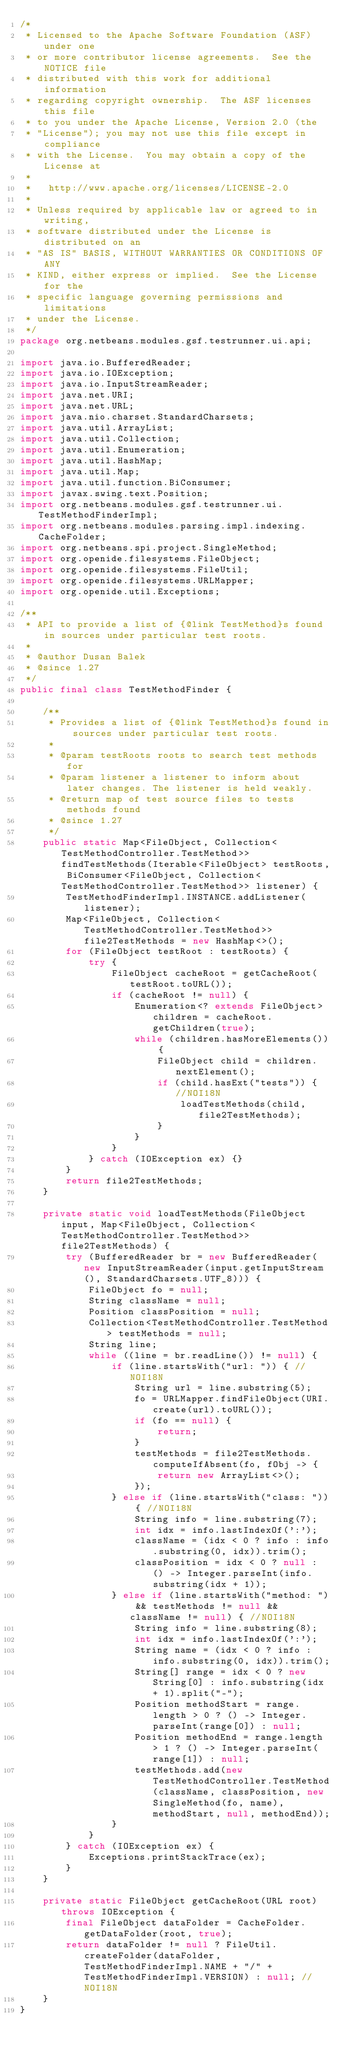Convert code to text. <code><loc_0><loc_0><loc_500><loc_500><_Java_>/*
 * Licensed to the Apache Software Foundation (ASF) under one
 * or more contributor license agreements.  See the NOTICE file
 * distributed with this work for additional information
 * regarding copyright ownership.  The ASF licenses this file
 * to you under the Apache License, Version 2.0 (the
 * "License"); you may not use this file except in compliance
 * with the License.  You may obtain a copy of the License at
 *
 *   http://www.apache.org/licenses/LICENSE-2.0
 *
 * Unless required by applicable law or agreed to in writing,
 * software distributed under the License is distributed on an
 * "AS IS" BASIS, WITHOUT WARRANTIES OR CONDITIONS OF ANY
 * KIND, either express or implied.  See the License for the
 * specific language governing permissions and limitations
 * under the License.
 */
package org.netbeans.modules.gsf.testrunner.ui.api;

import java.io.BufferedReader;
import java.io.IOException;
import java.io.InputStreamReader;
import java.net.URI;
import java.net.URL;
import java.nio.charset.StandardCharsets;
import java.util.ArrayList;
import java.util.Collection;
import java.util.Enumeration;
import java.util.HashMap;
import java.util.Map;
import java.util.function.BiConsumer;
import javax.swing.text.Position;
import org.netbeans.modules.gsf.testrunner.ui.TestMethodFinderImpl;
import org.netbeans.modules.parsing.impl.indexing.CacheFolder;
import org.netbeans.spi.project.SingleMethod;
import org.openide.filesystems.FileObject;
import org.openide.filesystems.FileUtil;
import org.openide.filesystems.URLMapper;
import org.openide.util.Exceptions;

/**
 * API to provide a list of {@link TestMethod}s found in sources under particular test roots.
 *
 * @author Dusan Balek
 * @since 1.27
 */
public final class TestMethodFinder {

    /**
     * Provides a list of {@link TestMethod}s found in sources under particular test roots.
     *
     * @param testRoots roots to search test methods for
     * @param listener a listener to inform about later changes. The listener is held weakly.
     * @return map of test source files to tests methods found
     * @since 1.27
     */
    public static Map<FileObject, Collection<TestMethodController.TestMethod>> findTestMethods(Iterable<FileObject> testRoots, BiConsumer<FileObject, Collection<TestMethodController.TestMethod>> listener) {
        TestMethodFinderImpl.INSTANCE.addListener(listener);
        Map<FileObject, Collection<TestMethodController.TestMethod>> file2TestMethods = new HashMap<>();
        for (FileObject testRoot : testRoots) {
            try {
                FileObject cacheRoot = getCacheRoot(testRoot.toURL());
                if (cacheRoot != null) {
                    Enumeration<? extends FileObject> children = cacheRoot.getChildren(true);
                    while (children.hasMoreElements()) {
                        FileObject child = children.nextElement();
                        if (child.hasExt("tests")) { //NOI18N
                            loadTestMethods(child, file2TestMethods);
                        }
                    }
                }
            } catch (IOException ex) {}
        }
        return file2TestMethods;
    }

    private static void loadTestMethods(FileObject input, Map<FileObject, Collection<TestMethodController.TestMethod>> file2TestMethods) {
        try (BufferedReader br = new BufferedReader(new InputStreamReader(input.getInputStream(), StandardCharsets.UTF_8))) {
            FileObject fo = null;
            String className = null;
            Position classPosition = null;
            Collection<TestMethodController.TestMethod> testMethods = null;
            String line;
            while ((line = br.readLine()) != null) {
                if (line.startsWith("url: ")) { //NOI18N
                    String url = line.substring(5);
                    fo = URLMapper.findFileObject(URI.create(url).toURL());
                    if (fo == null) {
                        return;
                    }
                    testMethods = file2TestMethods.computeIfAbsent(fo, fObj -> {
                        return new ArrayList<>();
                    });
                } else if (line.startsWith("class: ")) { //NOI18N
                    String info = line.substring(7);
                    int idx = info.lastIndexOf(':');
                    className = (idx < 0 ? info : info.substring(0, idx)).trim();
                    classPosition = idx < 0 ? null : () -> Integer.parseInt(info.substring(idx + 1));
                } else if (line.startsWith("method: ") && testMethods != null && className != null) { //NOI18N
                    String info = line.substring(8);
                    int idx = info.lastIndexOf(':');
                    String name = (idx < 0 ? info : info.substring(0, idx)).trim();
                    String[] range = idx < 0 ? new String[0] : info.substring(idx + 1).split("-");
                    Position methodStart = range.length > 0 ? () -> Integer.parseInt(range[0]) : null;
                    Position methodEnd = range.length > 1 ? () -> Integer.parseInt(range[1]) : null;
                    testMethods.add(new TestMethodController.TestMethod(className, classPosition, new SingleMethod(fo, name), methodStart, null, methodEnd));
                }
            }
        } catch (IOException ex) {
            Exceptions.printStackTrace(ex);
        }
    }

    private static FileObject getCacheRoot(URL root) throws IOException {
        final FileObject dataFolder = CacheFolder.getDataFolder(root, true);
        return dataFolder != null ? FileUtil.createFolder(dataFolder, TestMethodFinderImpl.NAME + "/" + TestMethodFinderImpl.VERSION) : null; //NOI18N
    }
}
</code> 